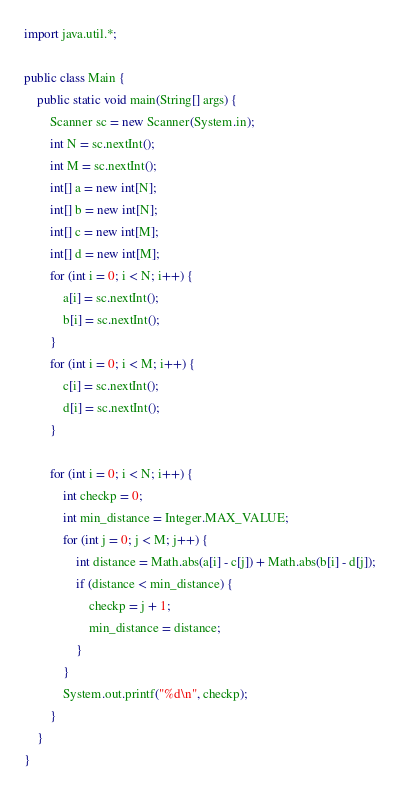Convert code to text. <code><loc_0><loc_0><loc_500><loc_500><_Java_>import java.util.*;

public class Main {
	public static void main(String[] args) {
		Scanner sc = new Scanner(System.in);
		int N = sc.nextInt();
		int M = sc.nextInt();
		int[] a = new int[N];
		int[] b = new int[N];
		int[] c = new int[M];
		int[] d = new int[M];
		for (int i = 0; i < N; i++) {
			a[i] = sc.nextInt();
			b[i] = sc.nextInt();
		}
		for (int i = 0; i < M; i++) {
			c[i] = sc.nextInt();
			d[i] = sc.nextInt();
		}

		for (int i = 0; i < N; i++) {
			int checkp = 0;
			int min_distance = Integer.MAX_VALUE;
			for (int j = 0; j < M; j++) {
				int distance = Math.abs(a[i] - c[j]) + Math.abs(b[i] - d[j]);
				if (distance < min_distance) {
					checkp = j + 1;
					min_distance = distance;
				}
			}
			System.out.printf("%d\n", checkp);
		}
	}
}
</code> 